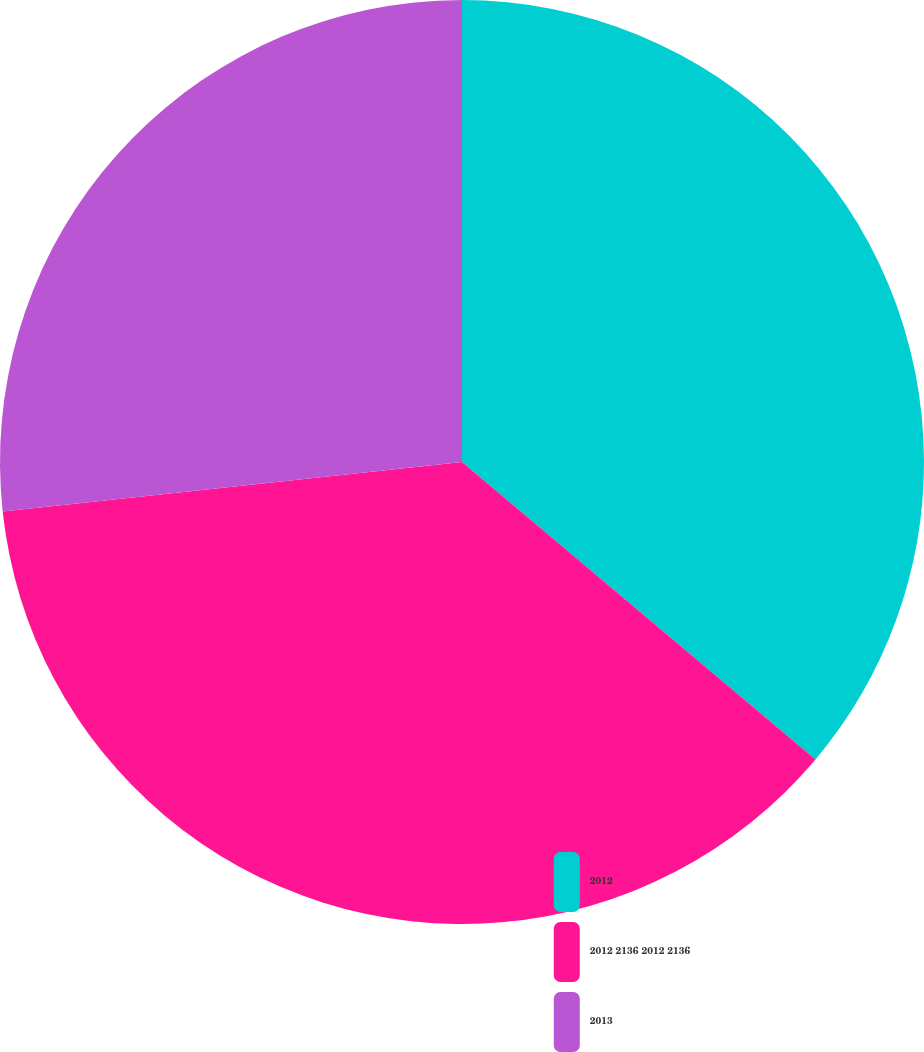Convert chart. <chart><loc_0><loc_0><loc_500><loc_500><pie_chart><fcel>2012<fcel>2012 2136 2012 2136<fcel>2013<nl><fcel>36.13%<fcel>37.15%<fcel>26.71%<nl></chart> 